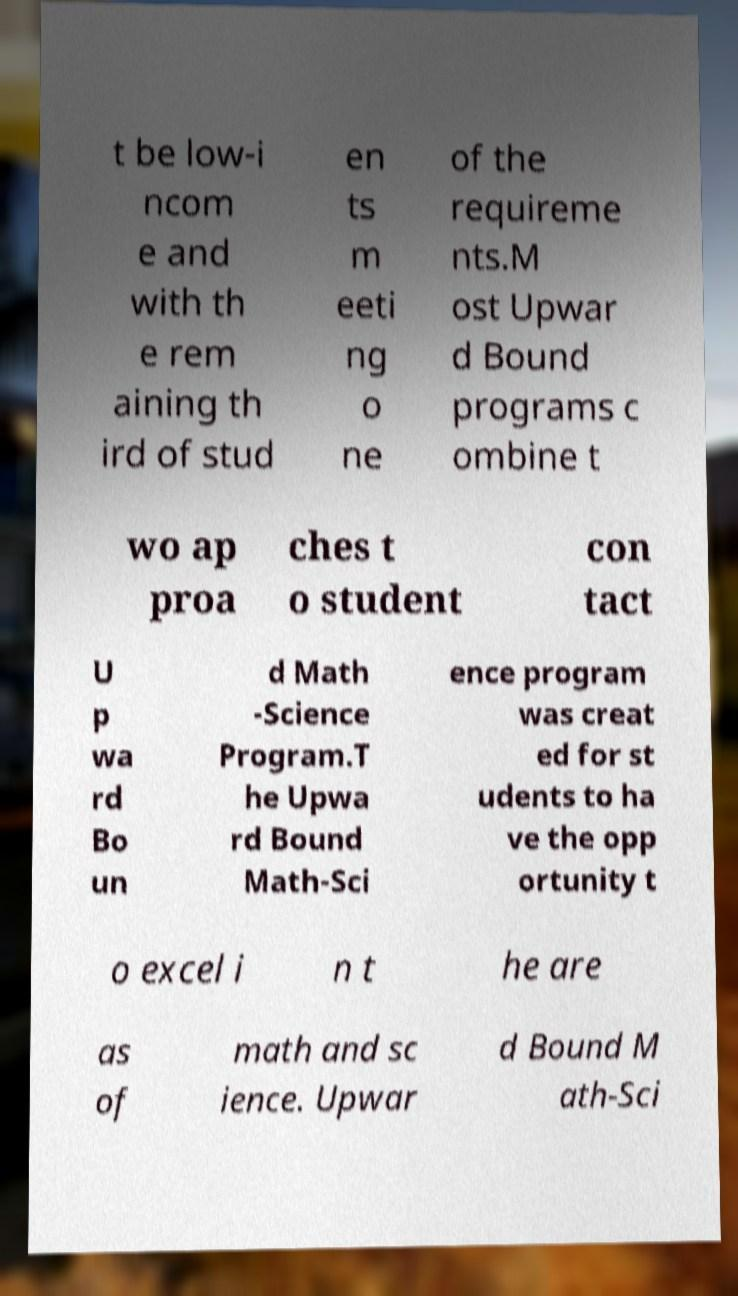I need the written content from this picture converted into text. Can you do that? t be low-i ncom e and with th e rem aining th ird of stud en ts m eeti ng o ne of the requireme nts.M ost Upwar d Bound programs c ombine t wo ap proa ches t o student con tact U p wa rd Bo un d Math -Science Program.T he Upwa rd Bound Math-Sci ence program was creat ed for st udents to ha ve the opp ortunity t o excel i n t he are as of math and sc ience. Upwar d Bound M ath-Sci 